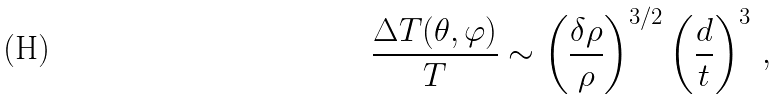<formula> <loc_0><loc_0><loc_500><loc_500>\frac { \Delta T ( \theta , \varphi ) } { T } \sim \left ( \frac { \delta \rho } { \rho } \right ) ^ { 3 / 2 } \left ( \frac { d } { t } \right ) ^ { 3 } \, ,</formula> 